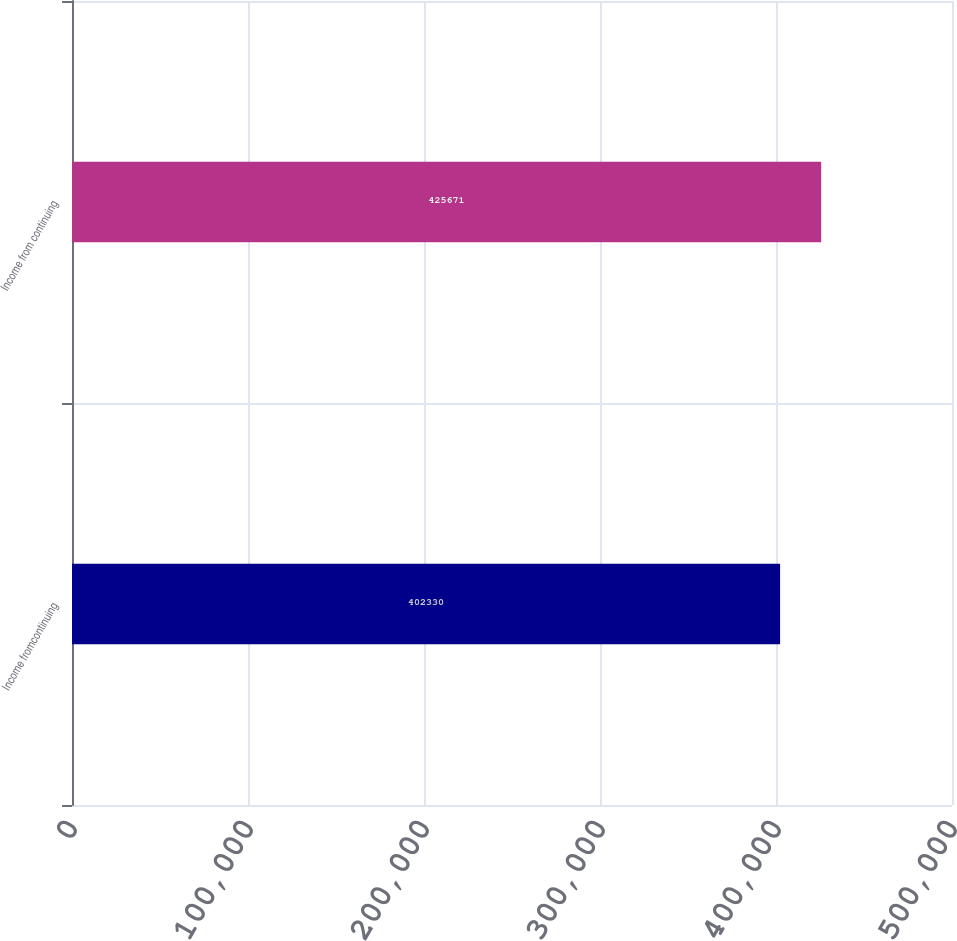<chart> <loc_0><loc_0><loc_500><loc_500><bar_chart><fcel>Income fromcontinuing<fcel>Income from continuing<nl><fcel>402330<fcel>425671<nl></chart> 